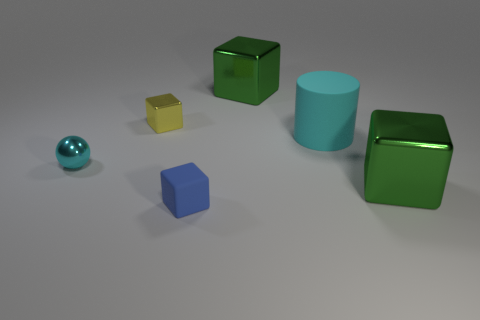Are there fewer tiny spheres than big green cubes?
Offer a very short reply. Yes. Are there any tiny blocks that have the same material as the cylinder?
Your response must be concise. Yes. There is a cyan thing that is in front of the large matte thing; what is its shape?
Your answer should be very brief. Sphere. There is a rubber thing that is behind the blue matte thing; does it have the same color as the tiny sphere?
Ensure brevity in your answer.  Yes. Are there fewer tiny matte things that are right of the tiny blue object than green objects?
Provide a short and direct response. Yes. There is a big cylinder that is the same material as the blue thing; what color is it?
Ensure brevity in your answer.  Cyan. There is a green block that is behind the tiny metal sphere; what is its size?
Your answer should be very brief. Large. Does the small blue cube have the same material as the large cyan thing?
Provide a succinct answer. Yes. Are there any big things to the left of the green shiny block in front of the large green object that is behind the small metal cube?
Keep it short and to the point. Yes. What color is the small rubber block?
Make the answer very short. Blue. 